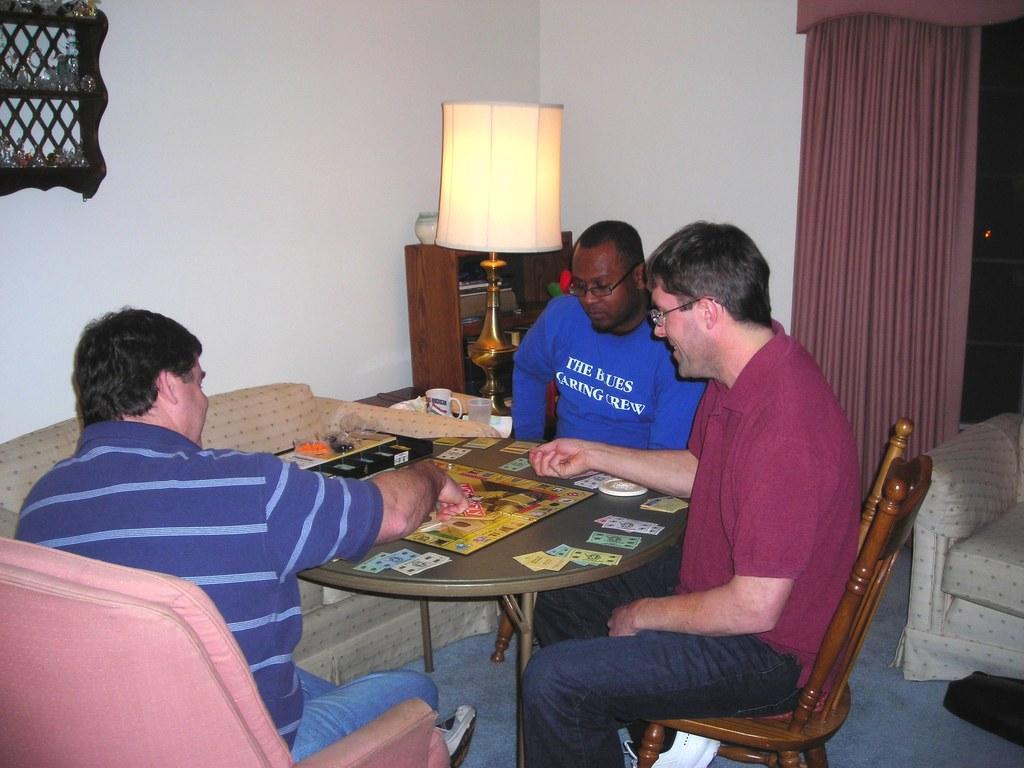Can you describe this image briefly? In this picture we can see three man sitting on chair and in front of them there is a table and on table we can see cards and beside to them there is sofa, cup, glass lamp, rack,wall, curtains. 